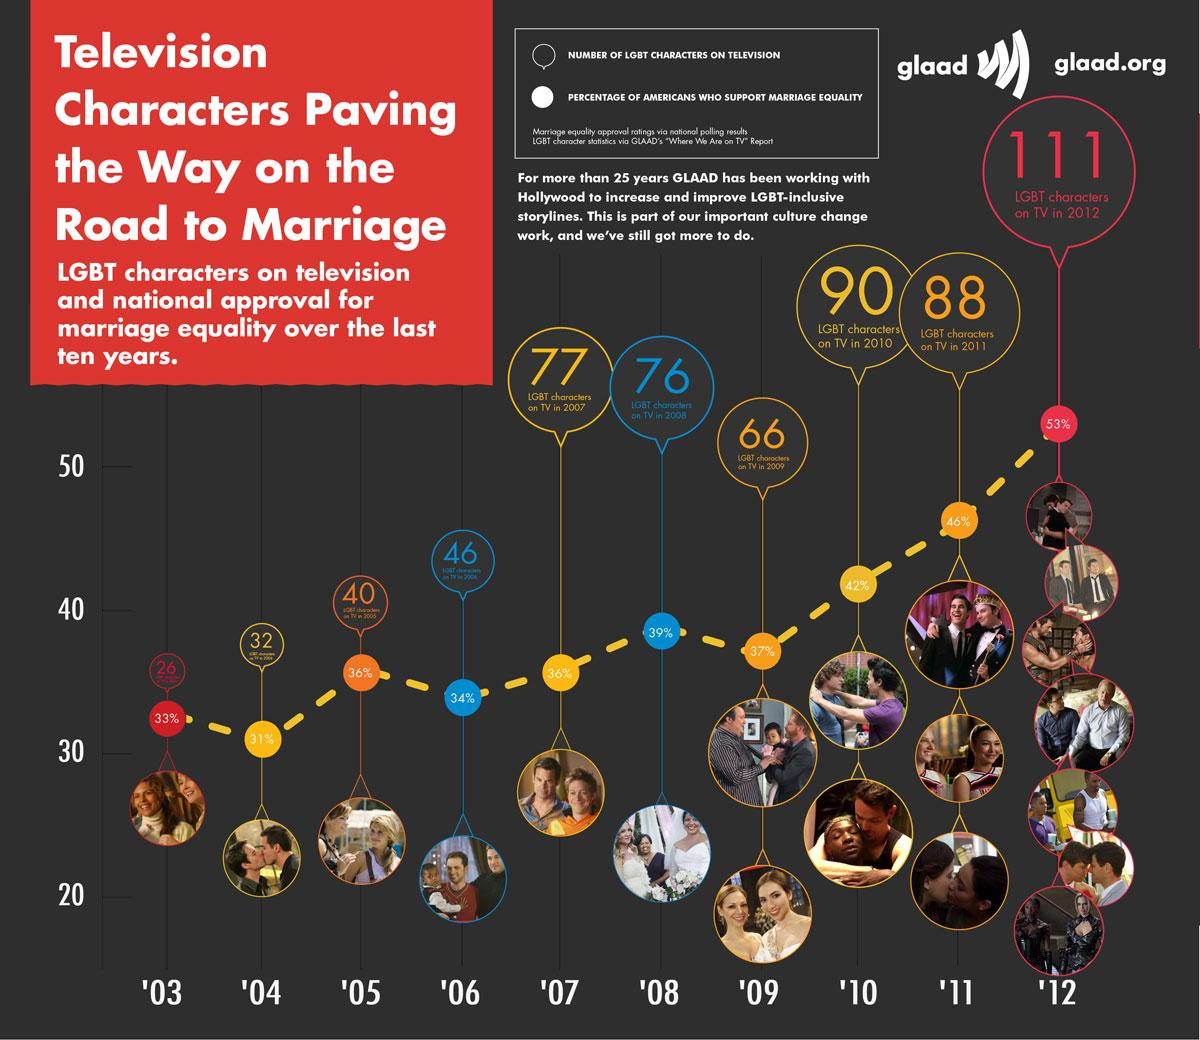Identify some key points in this picture. In 2005, approximately 36% of the characters shown on TV were gay. In 2009, 66 LGBT characters were depicted on television. In the year 2012, there were the most number of LGBT characters on TV. There were three LGBT couples depicted in the year 2011. 